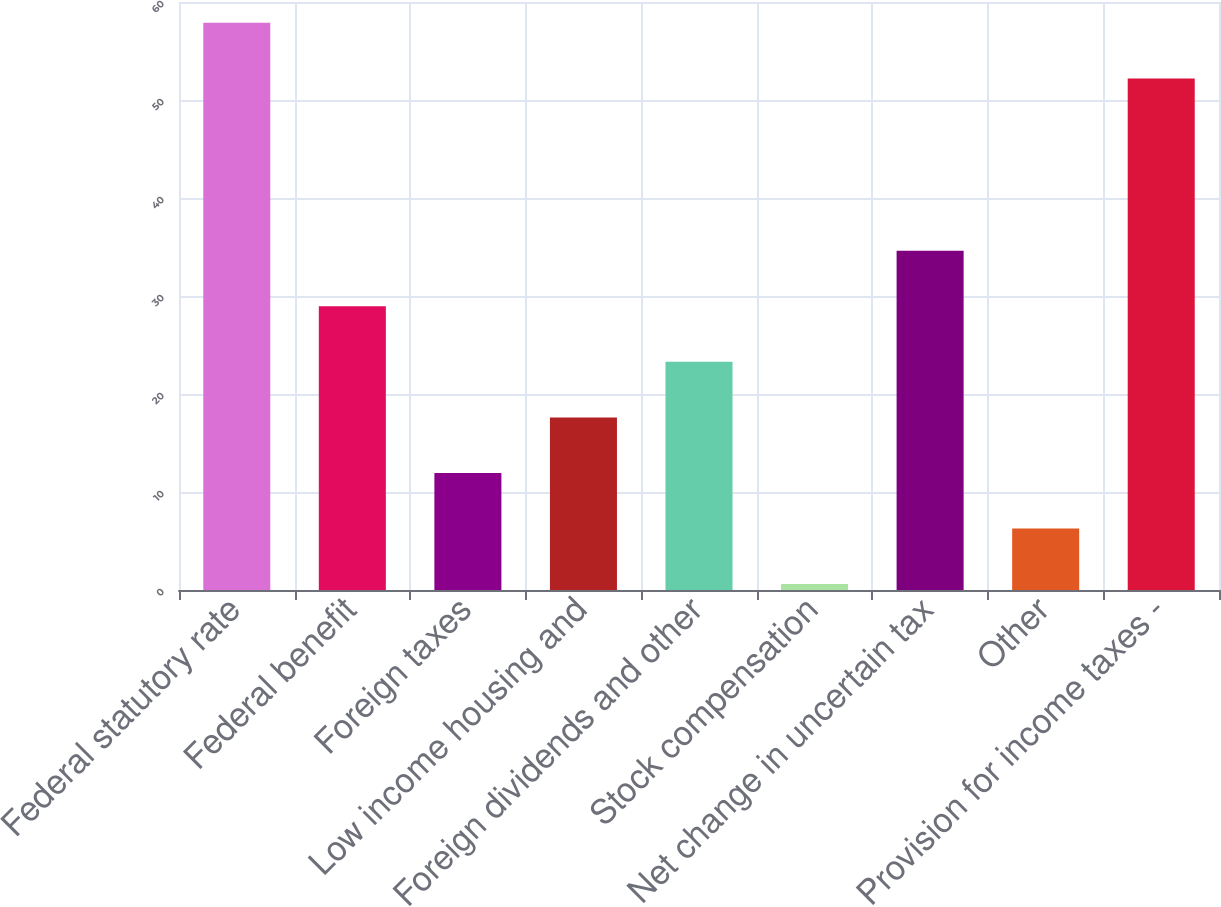<chart> <loc_0><loc_0><loc_500><loc_500><bar_chart><fcel>Federal statutory rate<fcel>Federal benefit<fcel>Foreign taxes<fcel>Low income housing and<fcel>Foreign dividends and other<fcel>Stock compensation<fcel>Net change in uncertain tax<fcel>Other<fcel>Provision for income taxes -<nl><fcel>57.87<fcel>28.95<fcel>11.94<fcel>17.61<fcel>23.28<fcel>0.6<fcel>34.62<fcel>6.27<fcel>52.2<nl></chart> 